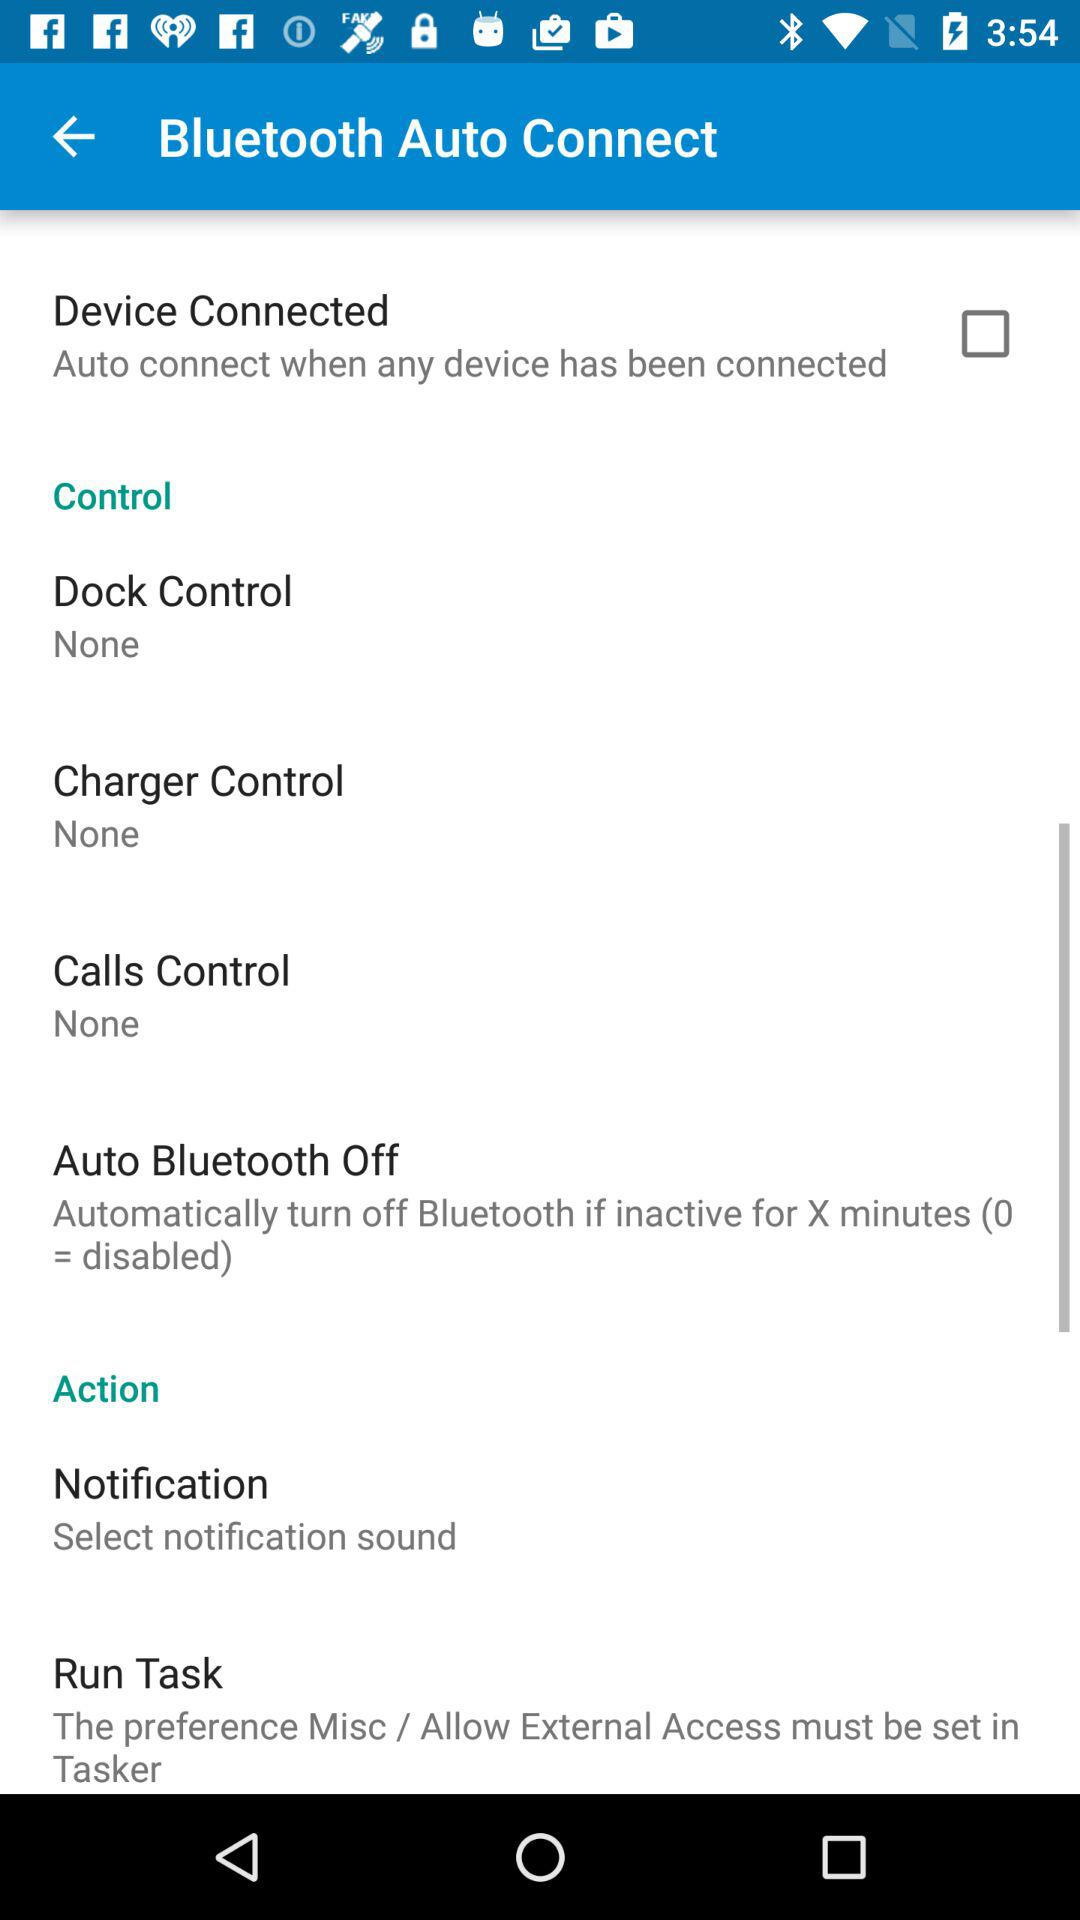What is the setting for charger control? The setting is "None". 